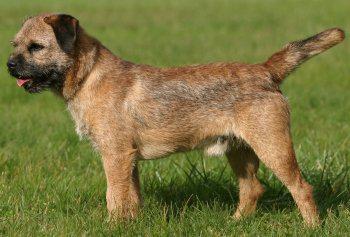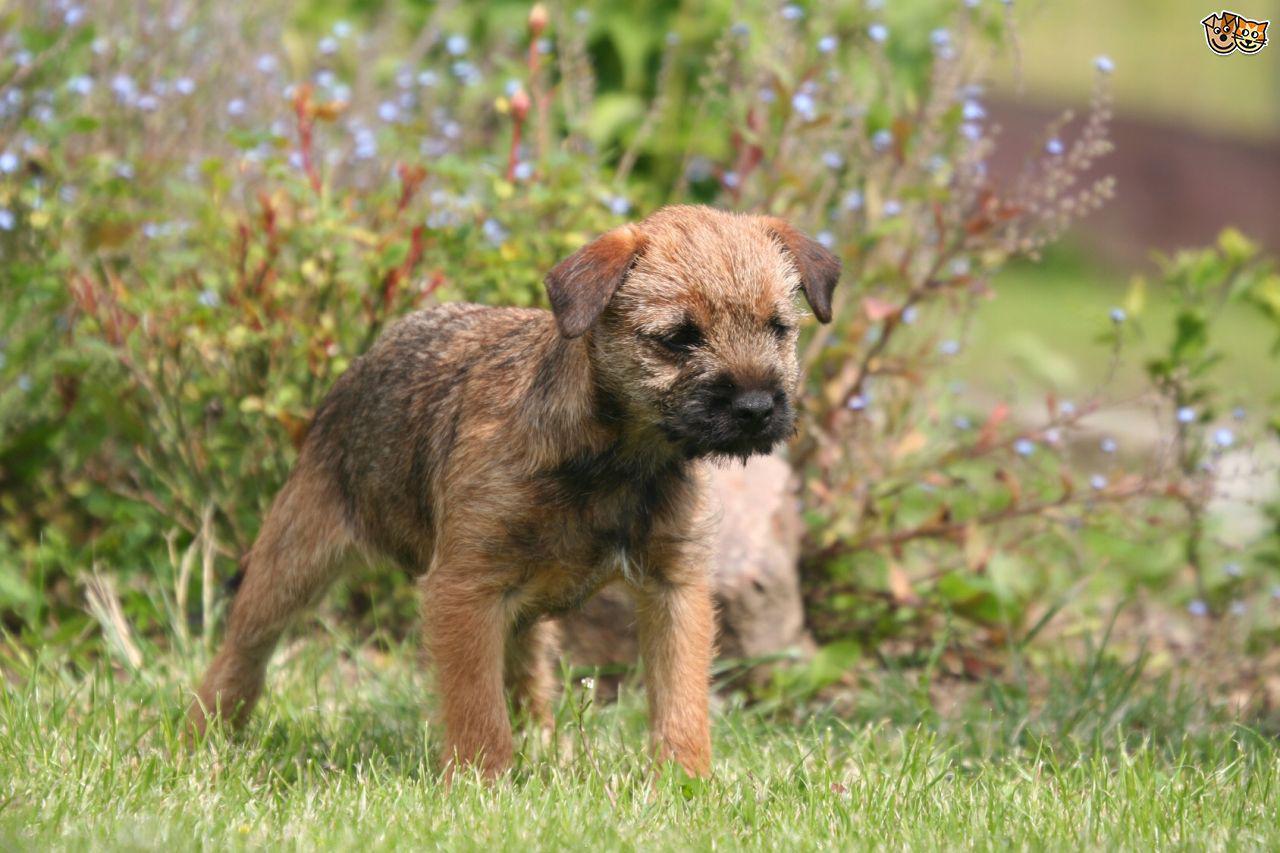The first image is the image on the left, the second image is the image on the right. For the images displayed, is the sentence "The animal in the image on the left is not looking toward the camera." factually correct? Answer yes or no. Yes. 